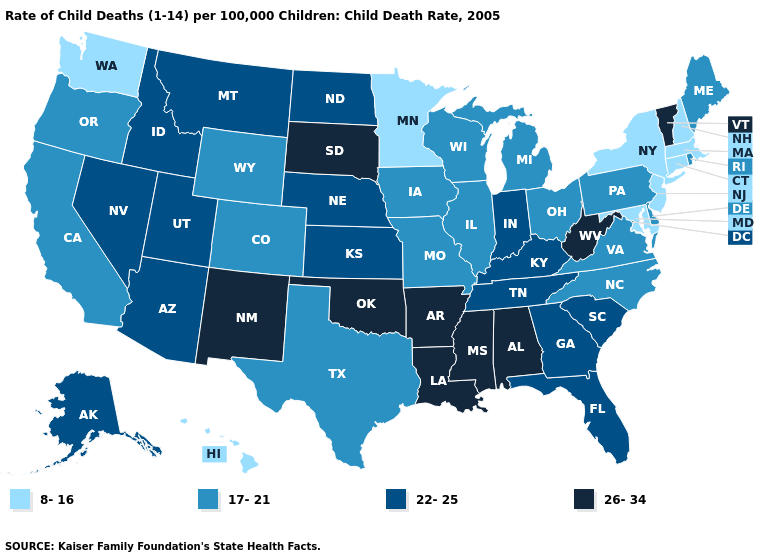Among the states that border Missouri , does Kentucky have the highest value?
Write a very short answer. No. Name the states that have a value in the range 8-16?
Keep it brief. Connecticut, Hawaii, Maryland, Massachusetts, Minnesota, New Hampshire, New Jersey, New York, Washington. What is the value of Alaska?
Be succinct. 22-25. Does Missouri have the lowest value in the USA?
Write a very short answer. No. Does Georgia have the highest value in the South?
Quick response, please. No. Which states hav the highest value in the West?
Be succinct. New Mexico. Name the states that have a value in the range 26-34?
Be succinct. Alabama, Arkansas, Louisiana, Mississippi, New Mexico, Oklahoma, South Dakota, Vermont, West Virginia. Does Indiana have the lowest value in the USA?
Write a very short answer. No. Name the states that have a value in the range 17-21?
Be succinct. California, Colorado, Delaware, Illinois, Iowa, Maine, Michigan, Missouri, North Carolina, Ohio, Oregon, Pennsylvania, Rhode Island, Texas, Virginia, Wisconsin, Wyoming. Name the states that have a value in the range 17-21?
Short answer required. California, Colorado, Delaware, Illinois, Iowa, Maine, Michigan, Missouri, North Carolina, Ohio, Oregon, Pennsylvania, Rhode Island, Texas, Virginia, Wisconsin, Wyoming. Does Massachusetts have the lowest value in the USA?
Concise answer only. Yes. What is the value of Oklahoma?
Be succinct. 26-34. What is the lowest value in the West?
Write a very short answer. 8-16. What is the highest value in states that border Arkansas?
Write a very short answer. 26-34. Name the states that have a value in the range 22-25?
Short answer required. Alaska, Arizona, Florida, Georgia, Idaho, Indiana, Kansas, Kentucky, Montana, Nebraska, Nevada, North Dakota, South Carolina, Tennessee, Utah. 